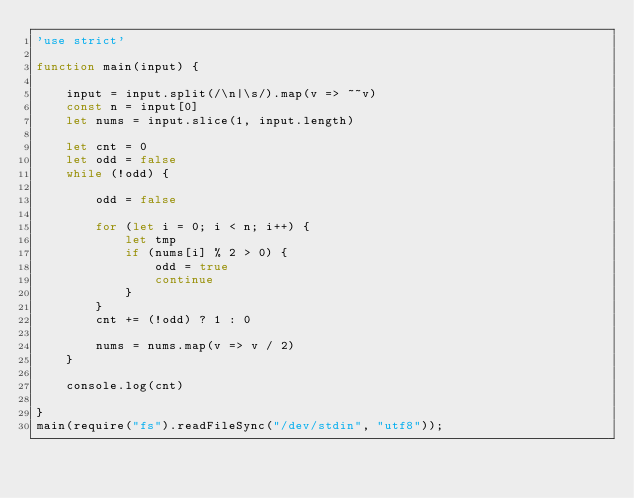Convert code to text. <code><loc_0><loc_0><loc_500><loc_500><_JavaScript_>'use strict'

function main(input) {

    input = input.split(/\n|\s/).map(v => ~~v)
    const n = input[0]
    let nums = input.slice(1, input.length)

    let cnt = 0
    let odd = false
    while (!odd) {

        odd = false

        for (let i = 0; i < n; i++) {
            let tmp
            if (nums[i] % 2 > 0) {
                odd = true
                continue
            }
        }
        cnt += (!odd) ? 1 : 0

        nums = nums.map(v => v / 2)
    }

    console.log(cnt)

}
main(require("fs").readFileSync("/dev/stdin", "utf8"));</code> 